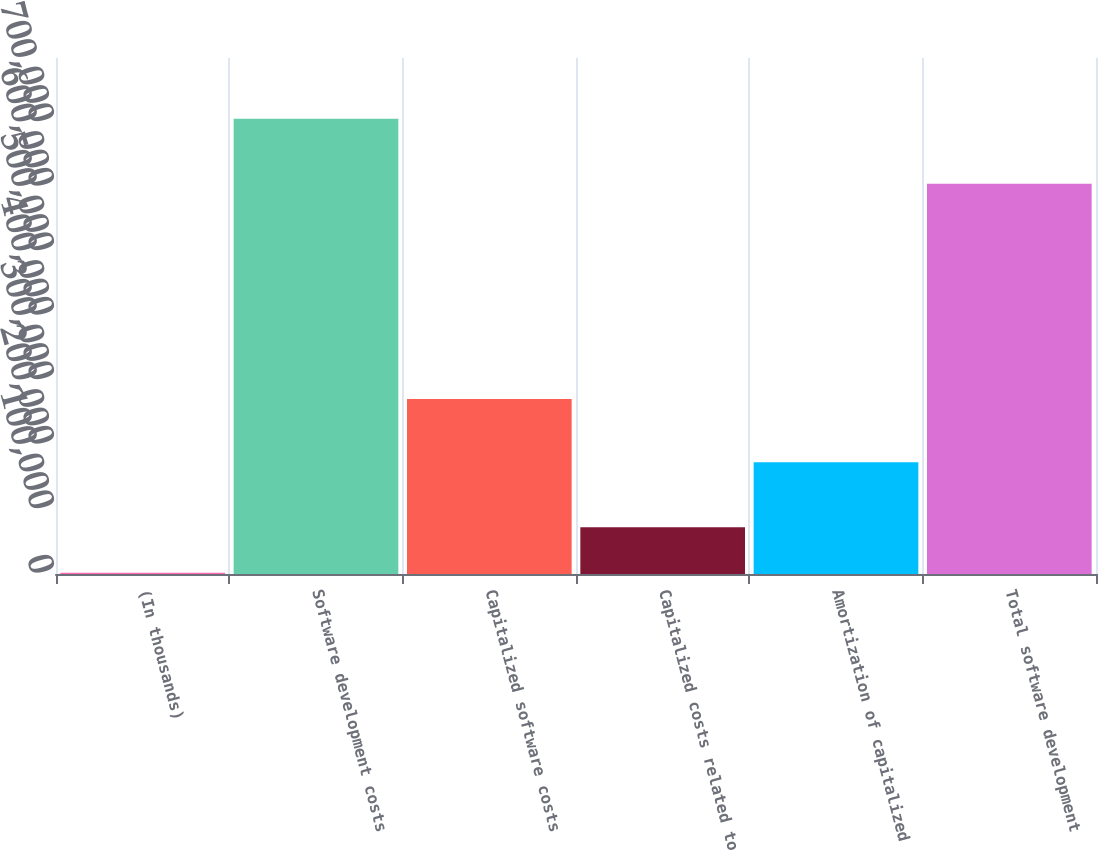<chart> <loc_0><loc_0><loc_500><loc_500><bar_chart><fcel>(In thousands)<fcel>Software development costs<fcel>Capitalized software costs<fcel>Capitalized costs related to<fcel>Amortization of capitalized<fcel>Total software development<nl><fcel>2017<fcel>705944<fcel>271411<fcel>72409.7<fcel>173250<fcel>605046<nl></chart> 